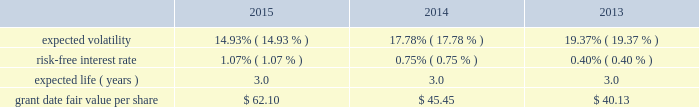During 2012 , the company granted selected employees an aggregate of 139 thousand rsus with internal performance measures and , separately , certain market thresholds .
These awards vested in january 2015 .
The terms of the grants specified that to the extent certain performance goals , comprised of internal measures and , separately , market thresholds were achieved , the rsus would vest ; if performance goals were surpassed , up to 175% ( 175 % ) of the target awards would be distributed ; and if performance goals were not met , the awards would be forfeited .
In january 2015 , an additional 93 thousand rsus were granted and distributed because performance thresholds were exceeded .
In 2015 , 2014 and 2013 , the company granted rsus , both with and without performance conditions , to certain employees under the 2007 plan .
The rsus without performance conditions vest ratably over the three- year service period beginning january 1 of the year of the grant and the rsus with performance conditions vest ratably over the three-year performance period beginning january 1 of the year of the grant ( the 201cperformance period 201d ) .
Distribution of the performance shares is contingent upon the achievement of internal performance measures and , separately , certain market thresholds over the performance period .
During 2015 , 2014 and 2013 , the company granted rsus to non-employee directors under the 2007 plan .
The rsus vested on the date of grant ; however , distribution of the shares will be made within 30 days of the earlier of : ( i ) 15 months after grant date , subject to any deferral election by the director ; or ( ii ) the participant 2019s separation from service .
Because these rsus vested on the grant date , the total grant date fair value was recorded in operation and maintenance expense included in the expense table above on the grant date .
Rsus generally vest over periods ranging from one to three years .
Rsus granted with service-only conditions and those with internal performance measures are valued at the market value of the closing price of the company 2019s common stock on the date of grant .
Rsus granted with market conditions are valued using a monte carlo model .
Expected volatility is based on historical volatilities of traded common stock of the company and comparative companies using daily stock prices over the past three years .
The expected term is three years and the risk-free interest rate is based on the three-year u.s .
Treasury rate in effect as of the measurement date .
The table presents the weighted-average assumptions used in the monte carlo simulation and the weighted-average grant date fair values of rsus granted for the years ended december 31: .
The grant date fair value of restricted stock awards that vest ratably and have market and/or performance and service conditions are amortized through expense over the requisite service period using the graded-vesting method .
Rsus that have no performance conditions are amortized through expense over the requisite service period using the straight-line method and are included in operations expense in the accompanying consolidated statements of operations .
As of december 31 , 2015 , $ 4 of total unrecognized compensation cost related to the nonvested restricted stock units is expected to be recognized over the weighted-average remaining life of 1.4 years .
The total grant date fair value of rsus vested was $ 12 , $ 11 and $ 9 for the years ended december 31 , 2015 , 2014 and 2013. .
What was the rate of growth from 2013 to 2014 in the fair value per share? 
Rationale: the growth rate of the fair value per share is the change from period to period divide by the base period
Computations: ((45.45 - 40.13) / 40.13)
Answer: 0.13257. 